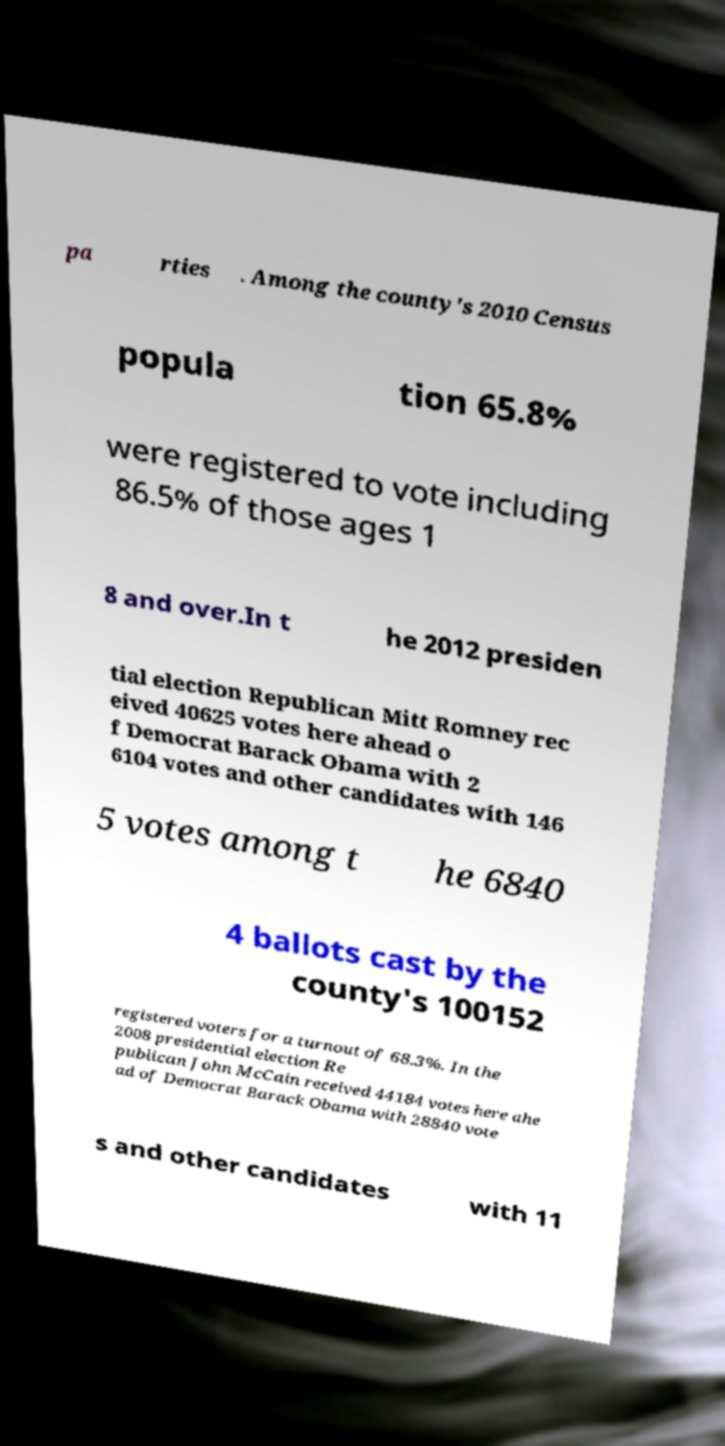Please identify and transcribe the text found in this image. pa rties . Among the county's 2010 Census popula tion 65.8% were registered to vote including 86.5% of those ages 1 8 and over.In t he 2012 presiden tial election Republican Mitt Romney rec eived 40625 votes here ahead o f Democrat Barack Obama with 2 6104 votes and other candidates with 146 5 votes among t he 6840 4 ballots cast by the county's 100152 registered voters for a turnout of 68.3%. In the 2008 presidential election Re publican John McCain received 44184 votes here ahe ad of Democrat Barack Obama with 28840 vote s and other candidates with 11 